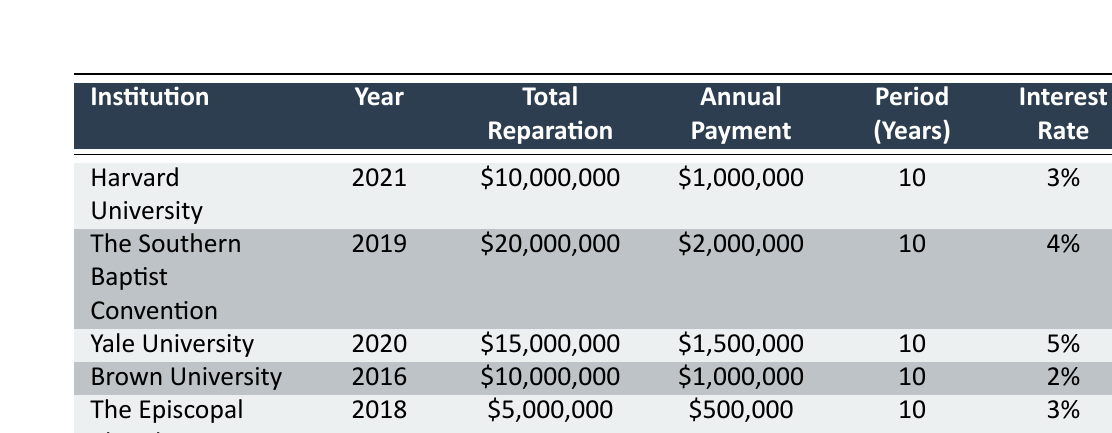What is the total reparation amount for Harvard University? The table explicitly lists the total reparation amount for Harvard University as $10,000,000. It can be found under the "Total Reparation" column corresponding to Harvard University in the first row.
Answer: $10,000,000 Which institution has the highest annual payment for reparations? Looking through the "Annual Payment" column, The Southern Baptist Convention has the highest value of $2,000,000 among all listed institutions, making it the one with the highest annual payment.
Answer: The Southern Baptist Convention How much will Brown University pay in total over the 10-year period? Brown University's annual payment is $1,000,000 for a payment period of 10 years; therefore, the total payment is calculated as $1,000,000 multiplied by 10, resulting in $10,000,000.
Answer: $10,000,000 Is the interest rate for reparations higher for Yale University than for Harvard University? Yale University has an interest rate of 5%, while Harvard University has an interest rate of 3%. Since 5% is greater than 3%, the statement is true.
Answer: Yes What is the average total reparation amount for the institutions listed? To find the average, sum the total reparation amounts ($10,000,000 + $20,000,000 + $15,000,000 + $10,000,000 + $5,000,000) which equals $60,000,000. Then, divide by the number of institutions (5), resulting in an average of $12,000,000.
Answer: $12,000,000 Which institution started paying reparations most recently? By checking the "Year" column, Harvard University in 2021 has the most recent date listed, indicating that it started paying reparations last.
Answer: Harvard University How many institutions have a total reparation amount of over $15 million? Checking the "Total Reparation" column reveals that The Southern Baptist Convention ($20,000,000) and Yale University ($15,000,000) are the only two with values above $15 million, resulting in a count of two institutions.
Answer: 2 If the total reparation amount for The Episcopal Church is $5,000,000, how much does it pay annually? The annual payment for The Episcopal Church is provided in the table as $500,000. This can be directly read from the corresponding row.
Answer: $500,000 